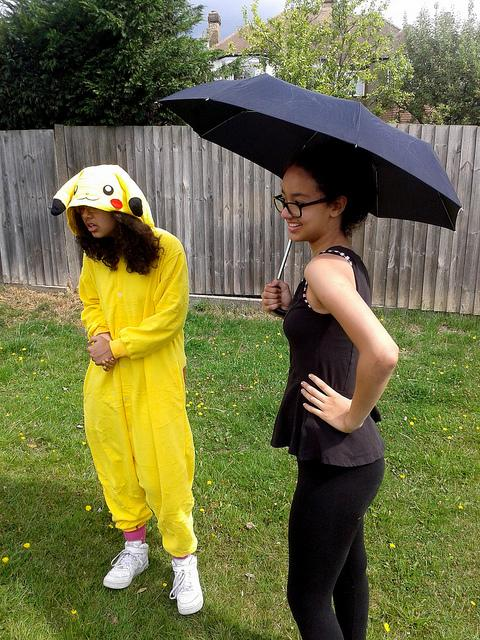What do the girls use the umbrella to avoid in this situation?

Choices:
A) sunburn
B) getting soaked
C) lightning
D) hail sunburn 